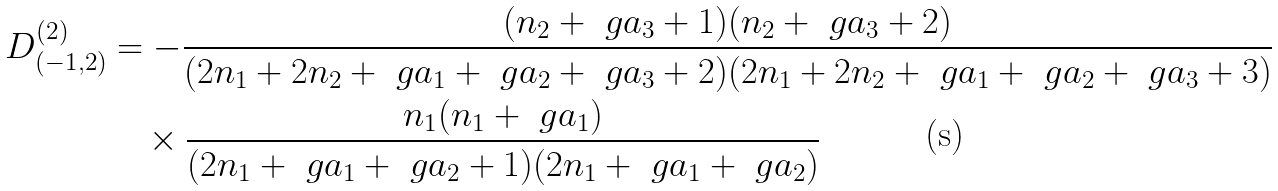Convert formula to latex. <formula><loc_0><loc_0><loc_500><loc_500>D _ { ( - 1 , 2 ) } ^ { ( 2 ) } & = - \frac { ( n _ { 2 } + \ g a _ { 3 } + 1 ) ( n _ { 2 } + \ g a _ { 3 } + 2 ) } { ( 2 n _ { 1 } + 2 n _ { 2 } + \ g a _ { 1 } + \ g a _ { 2 } + \ g a _ { 3 } + 2 ) ( 2 n _ { 1 } + 2 n _ { 2 } + \ g a _ { 1 } + \ g a _ { 2 } + \ g a _ { 3 } + 3 ) } \\ & \quad \times \frac { n _ { 1 } ( n _ { 1 } + \ g a _ { 1 } ) } { ( 2 n _ { 1 } + \ g a _ { 1 } + \ g a _ { 2 } + 1 ) ( 2 n _ { 1 } + \ g a _ { 1 } + \ g a _ { 2 } ) }</formula> 